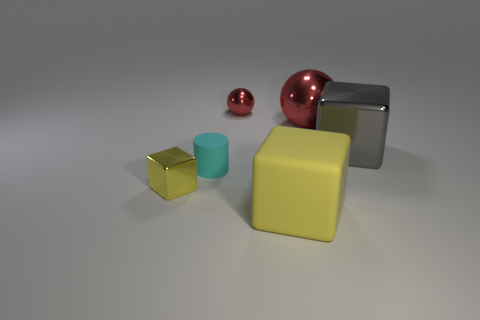Are there an equal number of tiny things behind the small metal cube and small yellow blocks?
Ensure brevity in your answer.  No. There is a block that is to the left of the small red metal thing; is there a yellow metallic block to the left of it?
Ensure brevity in your answer.  No. What number of other objects are the same color as the big metallic sphere?
Provide a succinct answer. 1. What color is the large matte block?
Make the answer very short. Yellow. What size is the thing that is both in front of the tiny matte thing and to the right of the cylinder?
Your answer should be compact. Large. What number of objects are small metal balls behind the big gray block or large brown rubber cylinders?
Offer a terse response. 1. There is a small cyan thing that is made of the same material as the large yellow block; what is its shape?
Provide a succinct answer. Cylinder. The small red metallic object has what shape?
Provide a succinct answer. Sphere. What color is the shiny object that is both behind the cyan rubber thing and on the left side of the big red shiny object?
Your answer should be very brief. Red. What is the shape of the other shiny thing that is the same size as the yellow metal object?
Ensure brevity in your answer.  Sphere. 